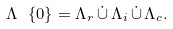<formula> <loc_0><loc_0><loc_500><loc_500>\Lambda \ \{ 0 \} = \Lambda _ { r } \, \dot { \cup } \, \Lambda _ { i } \, \dot { \cup } \, \Lambda _ { c } .</formula> 